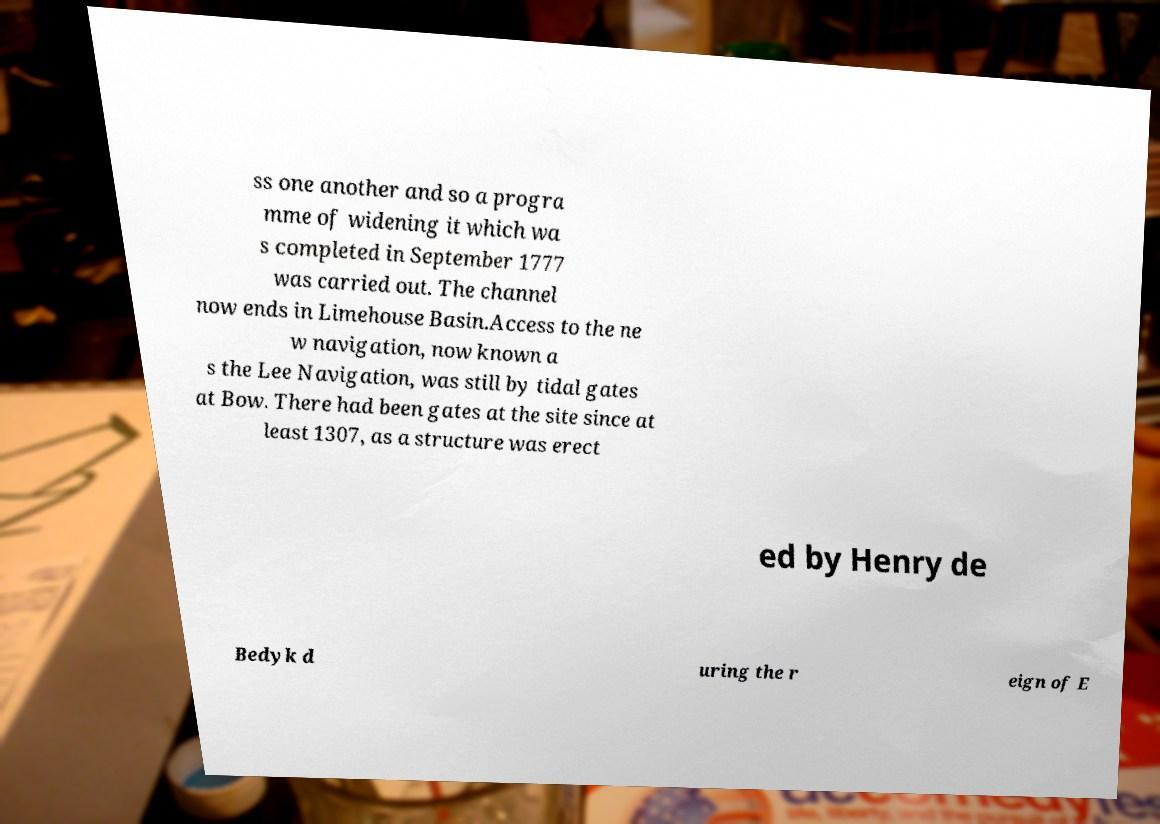Can you accurately transcribe the text from the provided image for me? ss one another and so a progra mme of widening it which wa s completed in September 1777 was carried out. The channel now ends in Limehouse Basin.Access to the ne w navigation, now known a s the Lee Navigation, was still by tidal gates at Bow. There had been gates at the site since at least 1307, as a structure was erect ed by Henry de Bedyk d uring the r eign of E 